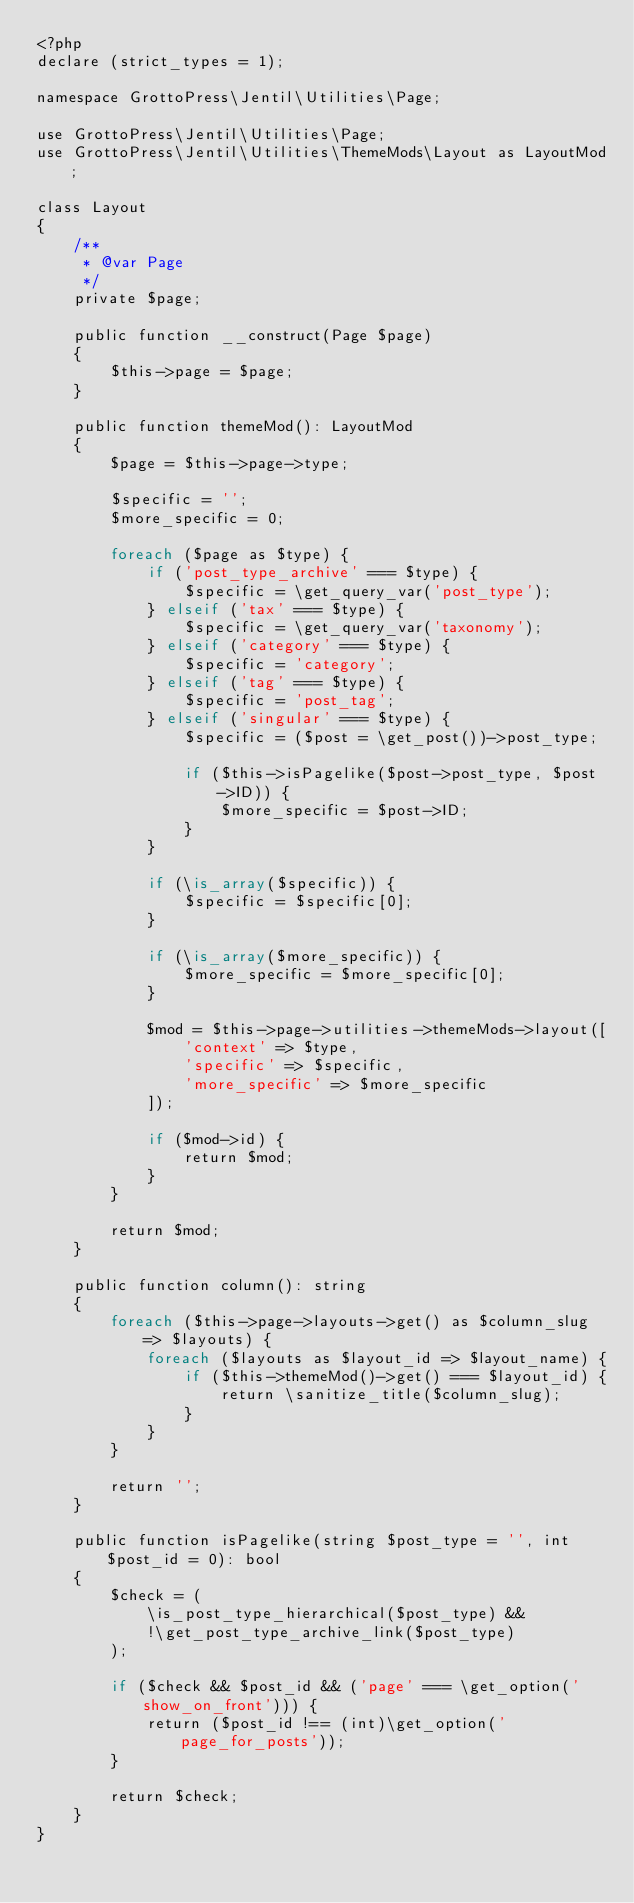<code> <loc_0><loc_0><loc_500><loc_500><_PHP_><?php
declare (strict_types = 1);

namespace GrottoPress\Jentil\Utilities\Page;

use GrottoPress\Jentil\Utilities\Page;
use GrottoPress\Jentil\Utilities\ThemeMods\Layout as LayoutMod;

class Layout
{
    /**
     * @var Page
     */
    private $page;

    public function __construct(Page $page)
    {
        $this->page = $page;
    }

    public function themeMod(): LayoutMod
    {
        $page = $this->page->type;

        $specific = '';
        $more_specific = 0;

        foreach ($page as $type) {
            if ('post_type_archive' === $type) {
                $specific = \get_query_var('post_type');
            } elseif ('tax' === $type) {
                $specific = \get_query_var('taxonomy');
            } elseif ('category' === $type) {
                $specific = 'category';
            } elseif ('tag' === $type) {
                $specific = 'post_tag';
            } elseif ('singular' === $type) {
                $specific = ($post = \get_post())->post_type;

                if ($this->isPagelike($post->post_type, $post->ID)) {
                    $more_specific = $post->ID;
                }
            }

            if (\is_array($specific)) {
                $specific = $specific[0];
            }

            if (\is_array($more_specific)) {
                $more_specific = $more_specific[0];
            }

            $mod = $this->page->utilities->themeMods->layout([
                'context' => $type,
                'specific' => $specific,
                'more_specific' => $more_specific
            ]);

            if ($mod->id) {
                return $mod;
            }
        }

        return $mod;
    }

    public function column(): string
    {
        foreach ($this->page->layouts->get() as $column_slug => $layouts) {
            foreach ($layouts as $layout_id => $layout_name) {
                if ($this->themeMod()->get() === $layout_id) {
                    return \sanitize_title($column_slug);
                }
            }
        }

        return '';
    }

    public function isPagelike(string $post_type = '', int $post_id = 0): bool
    {
        $check = (
            \is_post_type_hierarchical($post_type) &&
            !\get_post_type_archive_link($post_type)
        );

        if ($check && $post_id && ('page' === \get_option('show_on_front'))) {
            return ($post_id !== (int)\get_option('page_for_posts'));
        }

        return $check;
    }
}
</code> 